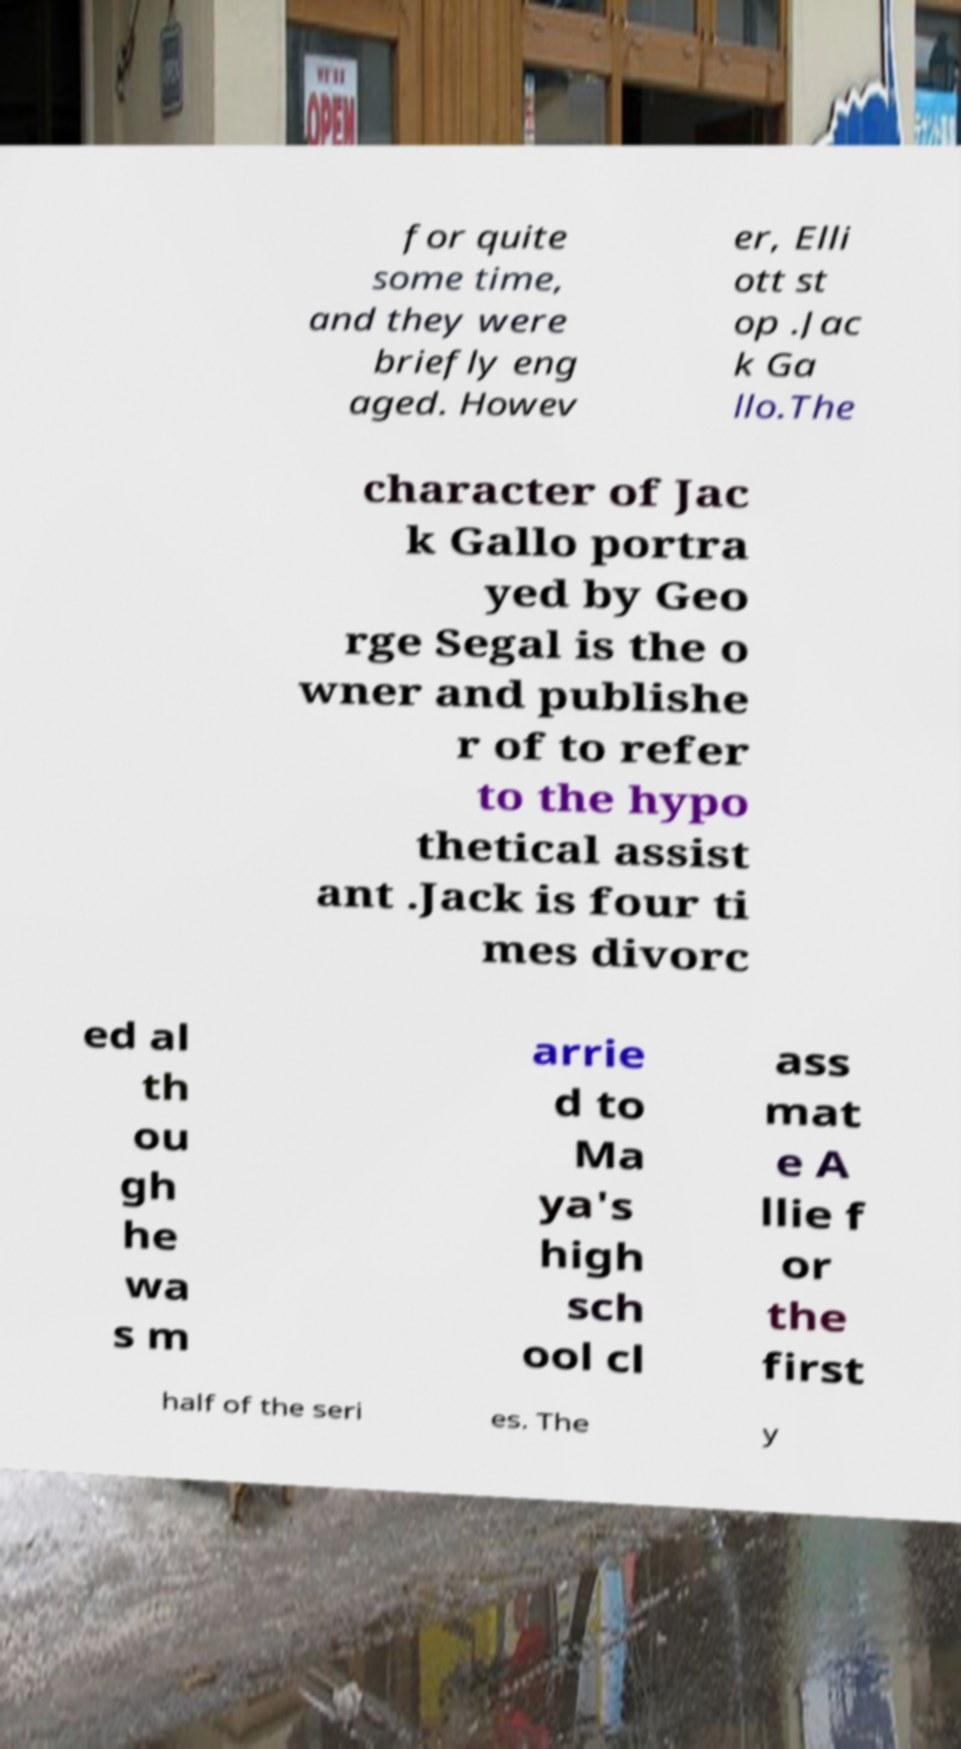For documentation purposes, I need the text within this image transcribed. Could you provide that? for quite some time, and they were briefly eng aged. Howev er, Elli ott st op .Jac k Ga llo.The character of Jac k Gallo portra yed by Geo rge Segal is the o wner and publishe r of to refer to the hypo thetical assist ant .Jack is four ti mes divorc ed al th ou gh he wa s m arrie d to Ma ya's high sch ool cl ass mat e A llie f or the first half of the seri es. The y 